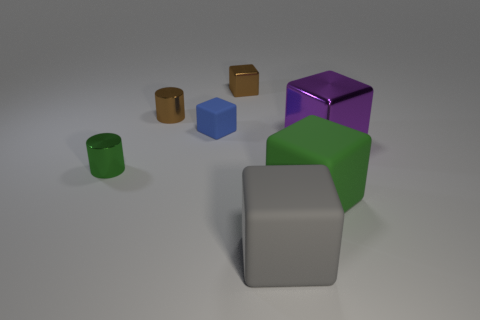There is a object that is behind the gray rubber object and in front of the small green shiny cylinder; what size is it?
Offer a terse response. Large. There is a object that is the same color as the small shiny block; what size is it?
Provide a short and direct response. Small. What number of other things are the same size as the gray thing?
Give a very brief answer. 2. What is the color of the matte block that is left of the small block that is behind the matte cube that is to the left of the gray rubber object?
Ensure brevity in your answer.  Blue. What shape is the shiny object that is both on the left side of the small brown cube and in front of the tiny matte block?
Your answer should be compact. Cylinder. What number of other things are the same shape as the tiny blue thing?
Your answer should be very brief. 4. The rubber object left of the shiny thing behind the tiny brown shiny object that is in front of the small metal cube is what shape?
Keep it short and to the point. Cube. How many objects are gray rubber cubes or metal things to the right of the green shiny cylinder?
Your answer should be compact. 4. Does the tiny thing that is in front of the purple thing have the same shape as the small blue thing behind the gray thing?
Make the answer very short. No. What number of things are either green metal spheres or large purple things?
Make the answer very short. 1. 